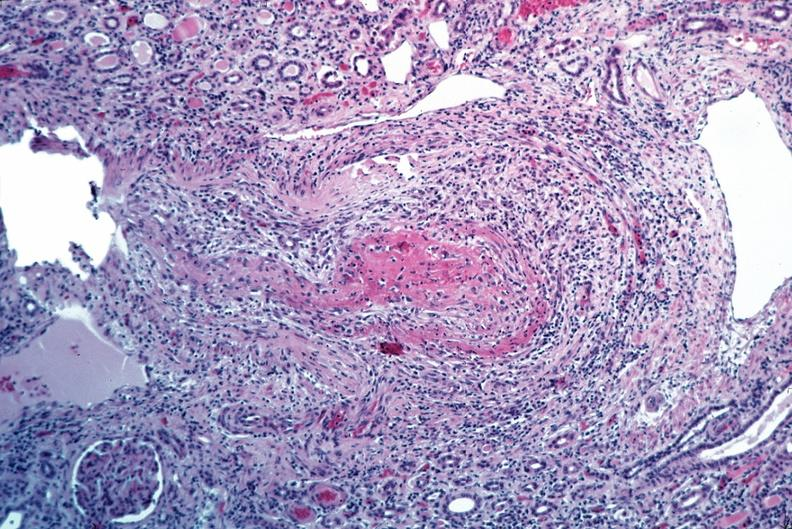s cardiovascular present?
Answer the question using a single word or phrase. Yes 